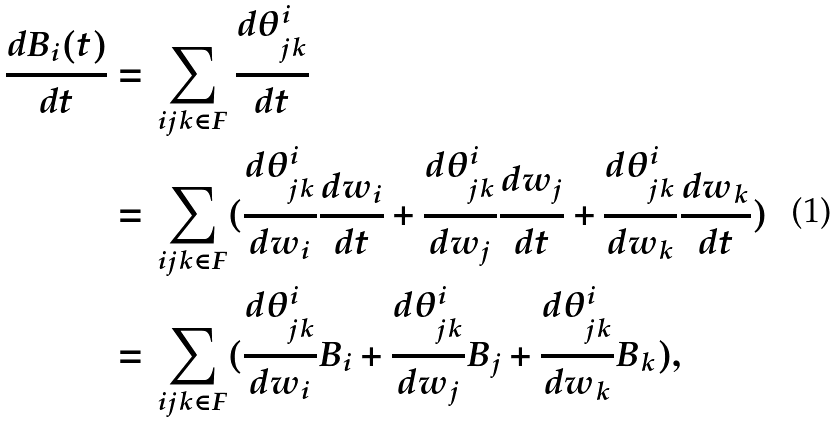Convert formula to latex. <formula><loc_0><loc_0><loc_500><loc_500>\frac { d B _ { i } ( t ) } { d t } = & \ \sum _ { i j k \in F } \frac { d \theta ^ { i } _ { j k } } { d t } \\ = & \ \sum _ { i j k \in F } ( \frac { d \theta ^ { i } _ { j k } } { d w _ { i } } \frac { d w _ { i } } { d t } + \frac { d \theta ^ { i } _ { j k } } { d w _ { j } } \frac { d w _ { j } } { d t } + \frac { d \theta ^ { i } _ { j k } } { d w _ { k } } \frac { d w _ { k } } { d t } ) \\ = & \ \sum _ { i j k \in F } ( \frac { d \theta ^ { i } _ { j k } } { d w _ { i } } B _ { i } + \frac { d \theta ^ { i } _ { j k } } { d w _ { j } } B _ { j } + \frac { d \theta ^ { i } _ { j k } } { d w _ { k } } B _ { k } ) ,</formula> 